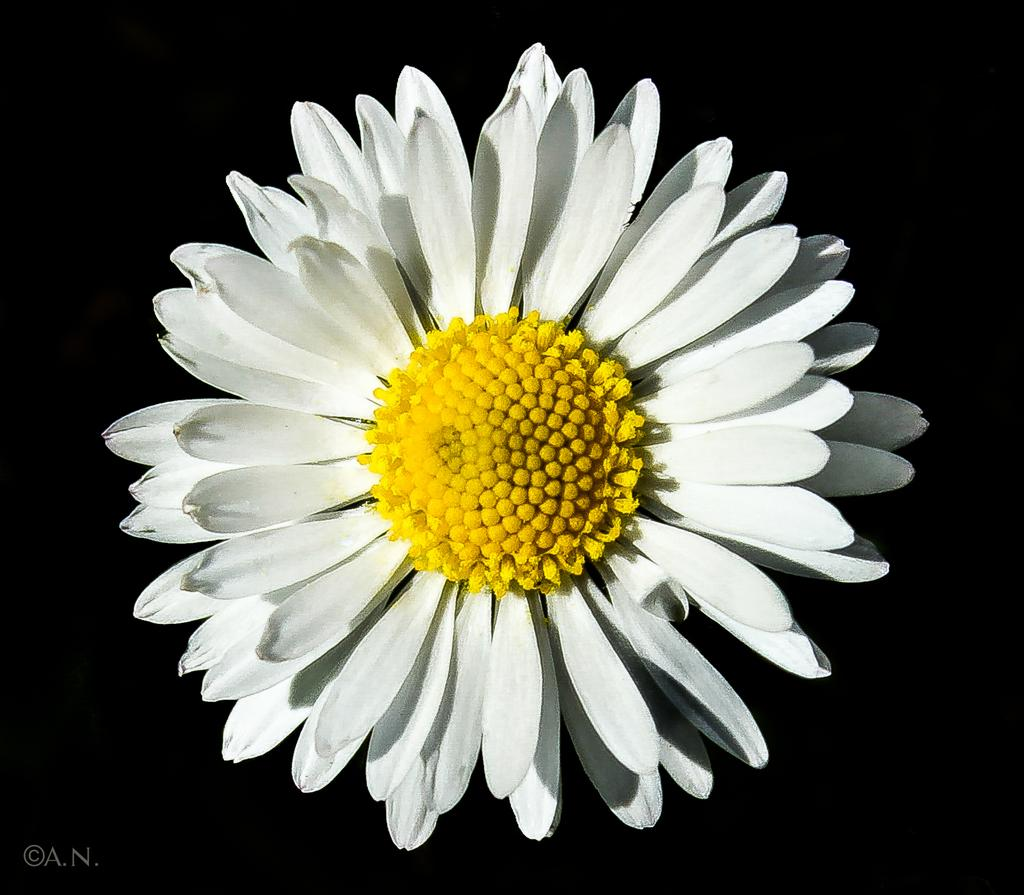What types of flowers are in the picture? There are white and yellow sunflowers in the picture. Is there any text or marking in the picture? Yes, there is a watermark at the bottom left corner of the picture. How would you describe the overall color scheme of the picture? The background of the picture is dark. What type of chalk is being used to draw on the sunflowers in the picture? There is no chalk or drawing present in the image; it features sunflowers and a watermark. Can you see a chessboard or chess pieces in the picture? No, there is no chessboard or chess pieces visible in the picture. 